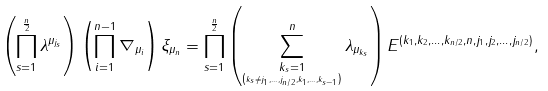<formula> <loc_0><loc_0><loc_500><loc_500>\left ( \prod _ { s = 1 } ^ { \frac { n } { 2 } } \lambda ^ { \mu _ { j _ { s } } } \right ) \left ( \prod _ { i = 1 } ^ { n - 1 } \nabla _ { \mu _ { i } } \right ) \xi _ { \mu _ { n } } = \prod _ { s = 1 } ^ { \frac { n } { 2 } } \left ( \sum _ { \underset { \left ( k _ { s } \ne j _ { 1 } , \dots , j _ { n / 2 } , k _ { 1 } , \dots , k _ { s - 1 } \right ) } { k _ { s } = 1 } } ^ { n } \lambda _ { \mu _ { k _ { s } } } \right ) E ^ { \left ( k _ { 1 } , k _ { 2 } , \dots , k _ { n / 2 } , n , j _ { 1 } , j _ { 2 } , \dots , j _ { n / 2 } \right ) } ,</formula> 